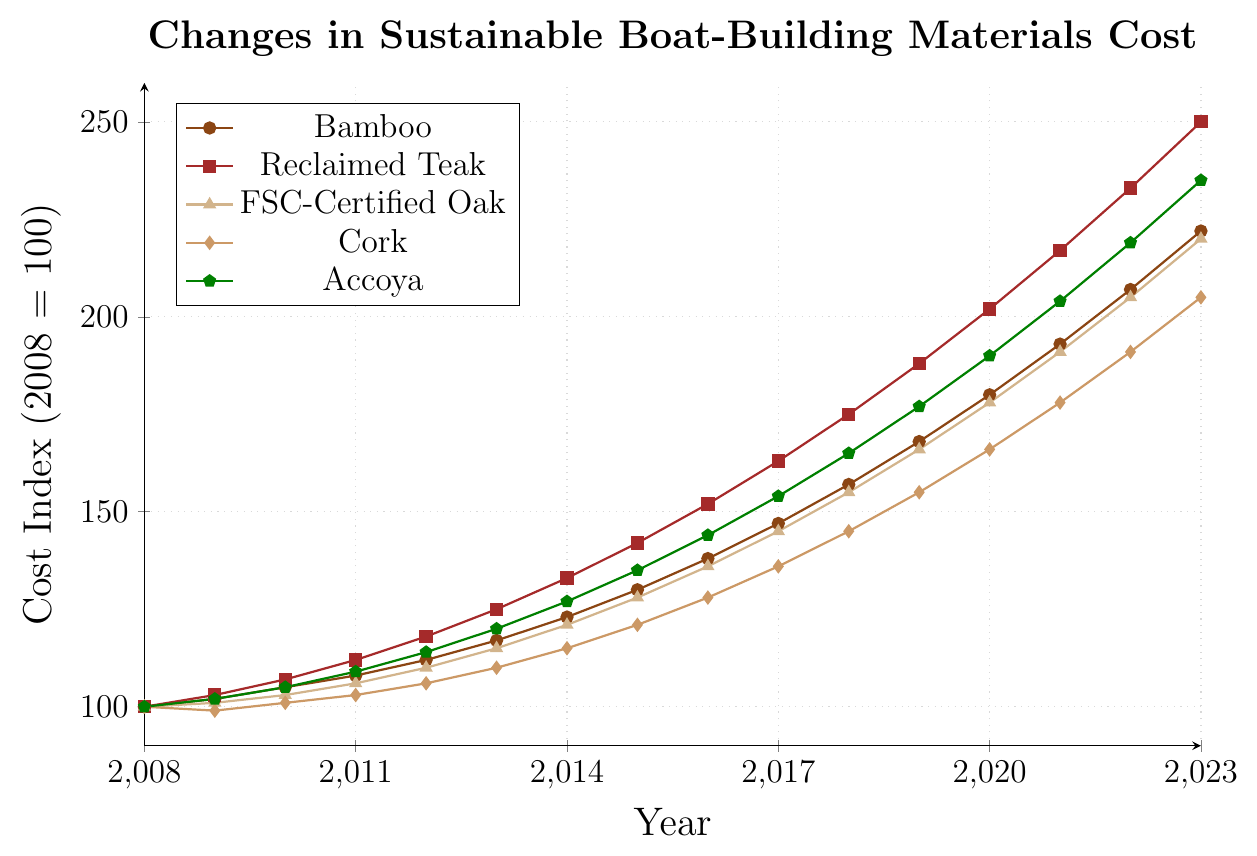Which material experienced the largest percentage increase in cost over the 15 years? To find the material with the largest percentage increase, we compare the initial (2008) and final (2023) cost indices for each material. Calculating the increase for each: Bamboo increased from 100 to 222 (122%), Reclaimed Teak from 100 to 250 (150%), FSC-Certified Oak from 100 to 220 (120%), Cork from 100 to 205 (105%), and Accoya from 100 to 235 (135%). Reclaimed Teak had the largest percentage increase.
Answer: Reclaimed Teak Which year did Accoya surpass a cost index of 200? Looking at the plot, Accoya's cost index first surpasses 200 in the year 2021.
Answer: 2021 By how much did the cost of Bamboo increase from 2008 to 2023? The cost of Bamboo in 2008 was 100 and it increased to 222 in 2023. The difference is 222 - 100 = 122.
Answer: 122 Compare the cost index of FSC-Certified Oak and Cork in 2020. Which is higher? In 2020, the cost index for FSC-Certified Oak is 178 and for Cork is 166. FSC-Certified Oak's cost index is higher.
Answer: FSC-Certified Oak What was the average cost index of all materials in the year 2015? To find the average cost index for 2015, sum the cost indices for Bamboo (130), Reclaimed Teak (142), FSC-Certified Oak (128), Cork (121), and Accoya (135) and divide by 5. (130 + 142 + 128 + 121 + 135) / 5 = 656 / 5 = 131.2.
Answer: 131.2 Which material had the highest cost index in 2018? By checking the data in 2018: Bamboo (157), Reclaimed Teak (175), FSC-Certified Oak (155), Cork (145), and Accoya (165). Reclaimed Teak has the highest cost index.
Answer: Reclaimed Teak How many years did it take for Cork's cost index to double from its 2008 value? Cork's cost index in 2008 is 100. It doubles to 200. This happens in 2021. It took 2021 - 2008 = 13 years.
Answer: 13 years Compare the rate of increase in cost index between Bamboo and Accoya over the 15-year period. Which increased faster? Bamboo increased from 100 to 222 (122%), and Accoya from 100 to 235 (135%). Accoya increased faster.
Answer: Accoya 